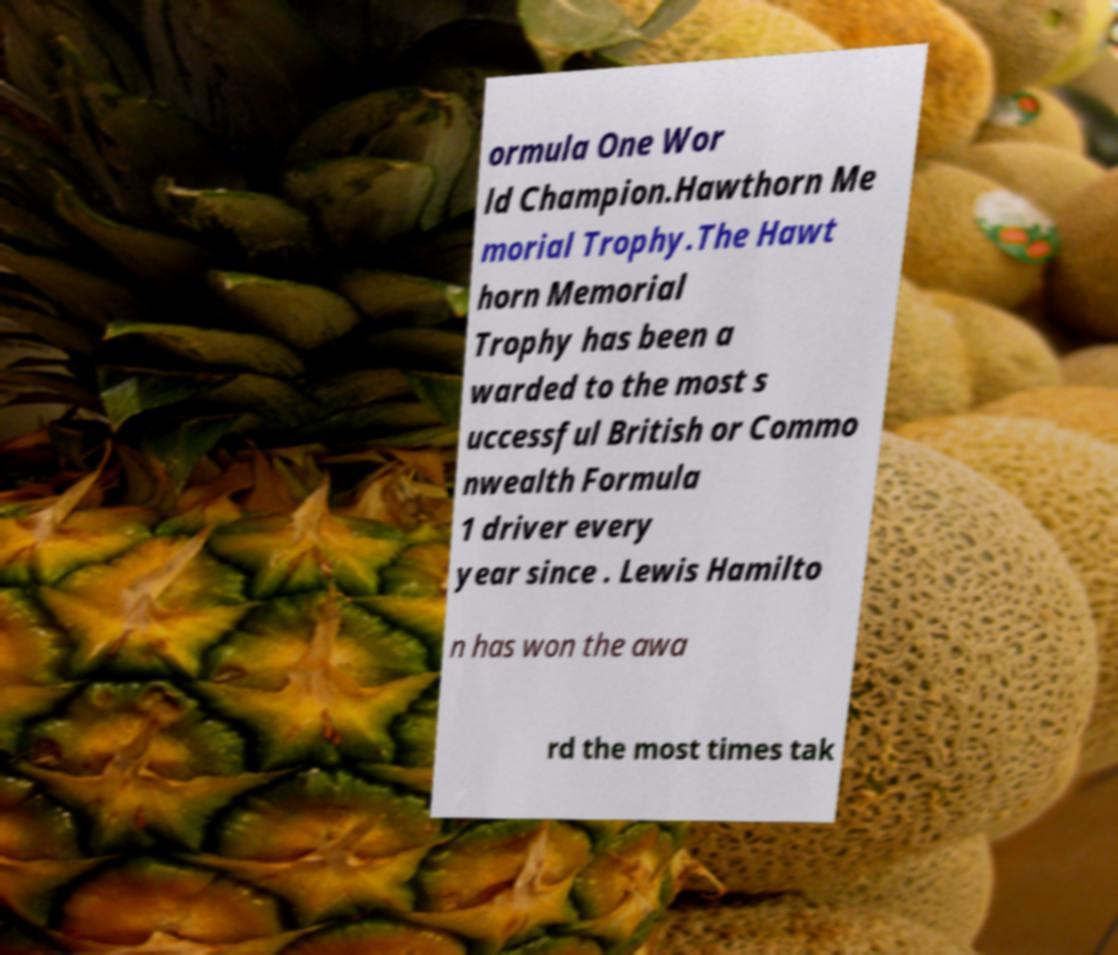What messages or text are displayed in this image? I need them in a readable, typed format. ormula One Wor ld Champion.Hawthorn Me morial Trophy.The Hawt horn Memorial Trophy has been a warded to the most s uccessful British or Commo nwealth Formula 1 driver every year since . Lewis Hamilto n has won the awa rd the most times tak 